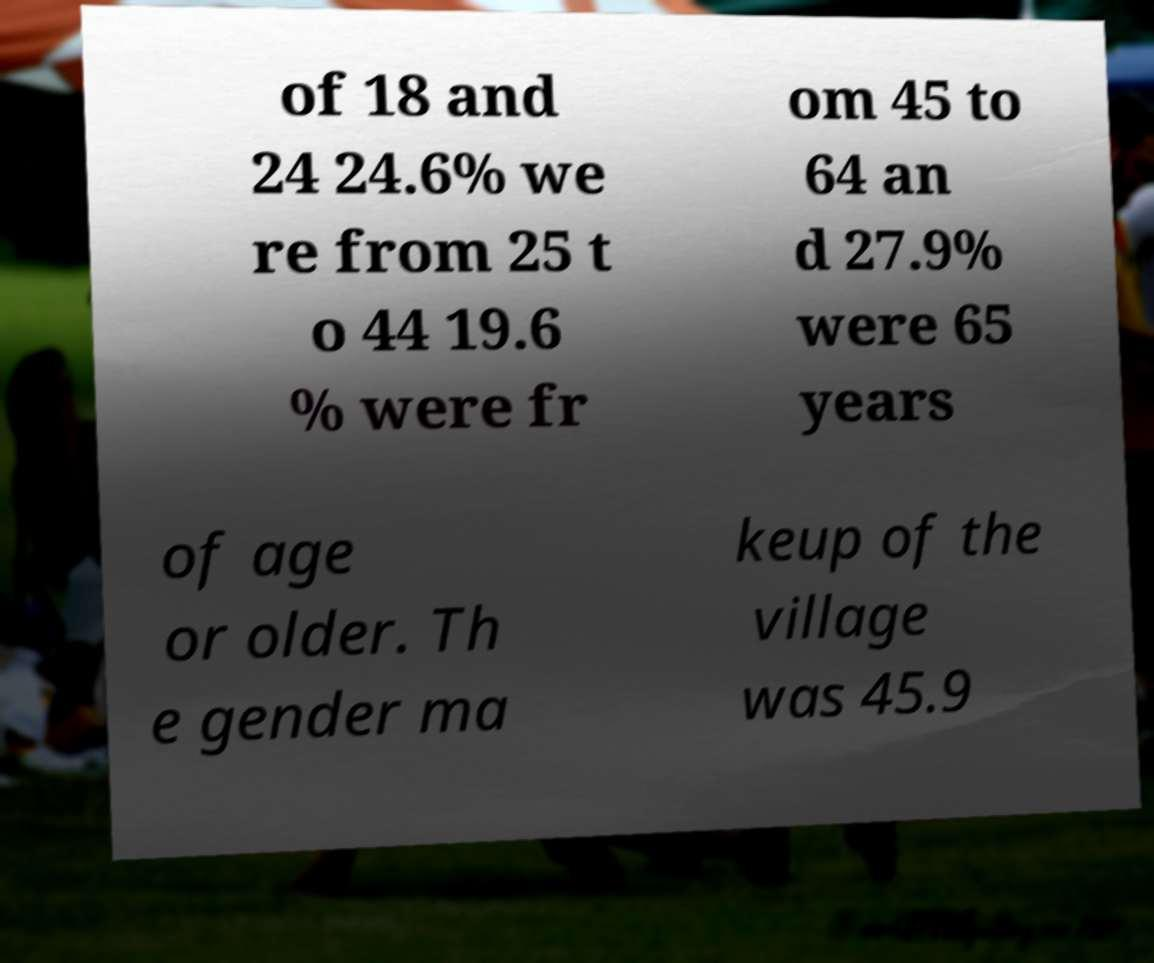Can you accurately transcribe the text from the provided image for me? of 18 and 24 24.6% we re from 25 t o 44 19.6 % were fr om 45 to 64 an d 27.9% were 65 years of age or older. Th e gender ma keup of the village was 45.9 